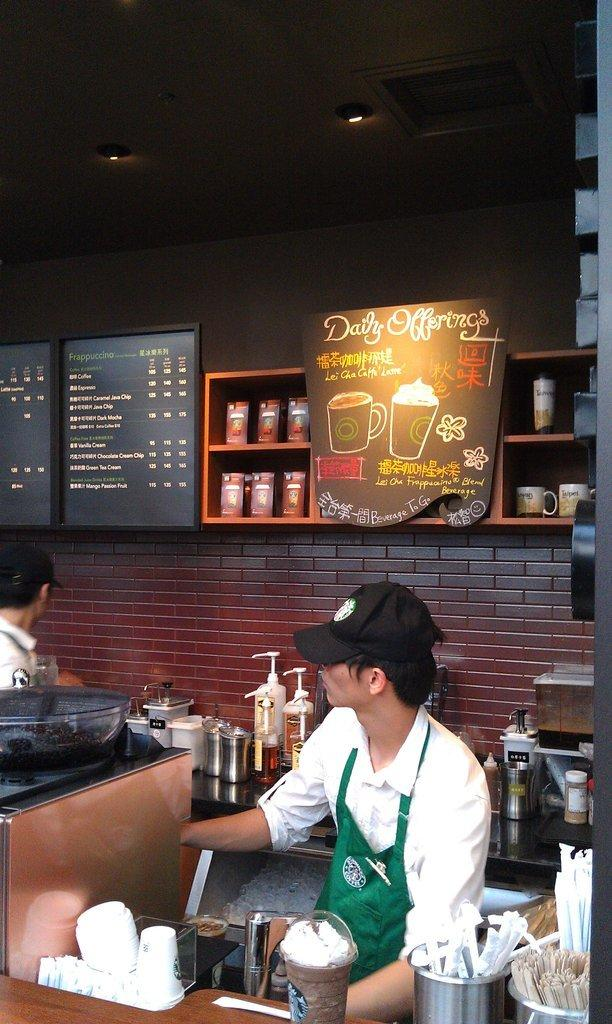Provide a one-sentence caption for the provided image. A daily offerings sign is on the wall behind the barista. 